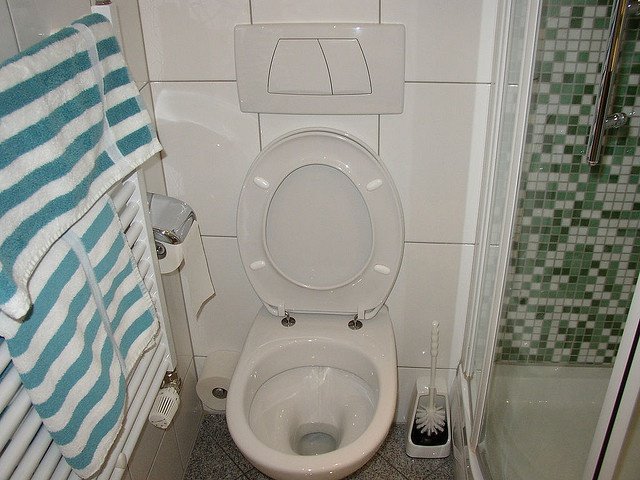Describe the objects in this image and their specific colors. I can see a toilet in gray and darkgray tones in this image. 